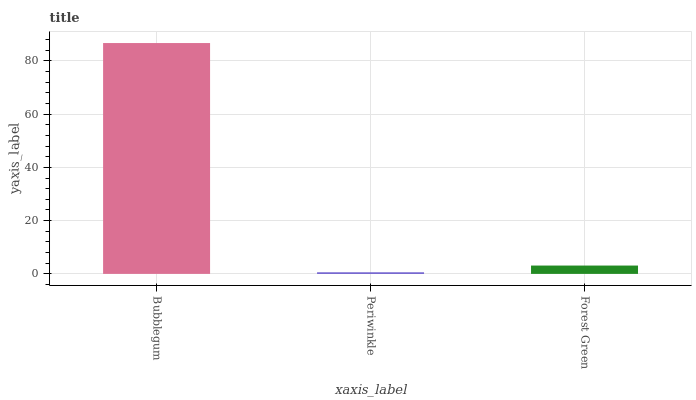Is Periwinkle the minimum?
Answer yes or no. Yes. Is Bubblegum the maximum?
Answer yes or no. Yes. Is Forest Green the minimum?
Answer yes or no. No. Is Forest Green the maximum?
Answer yes or no. No. Is Forest Green greater than Periwinkle?
Answer yes or no. Yes. Is Periwinkle less than Forest Green?
Answer yes or no. Yes. Is Periwinkle greater than Forest Green?
Answer yes or no. No. Is Forest Green less than Periwinkle?
Answer yes or no. No. Is Forest Green the high median?
Answer yes or no. Yes. Is Forest Green the low median?
Answer yes or no. Yes. Is Periwinkle the high median?
Answer yes or no. No. Is Periwinkle the low median?
Answer yes or no. No. 